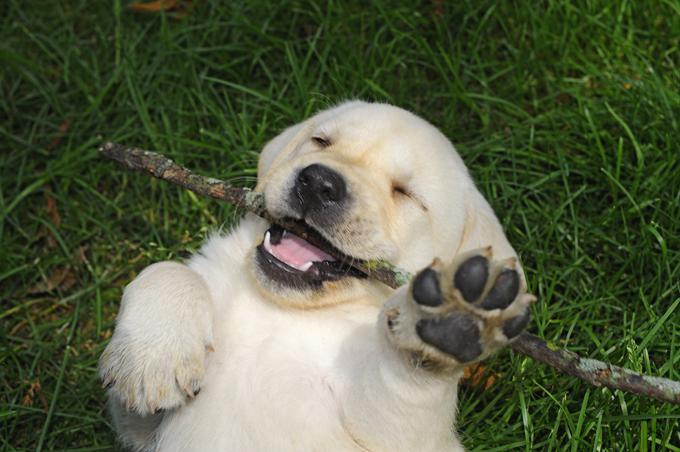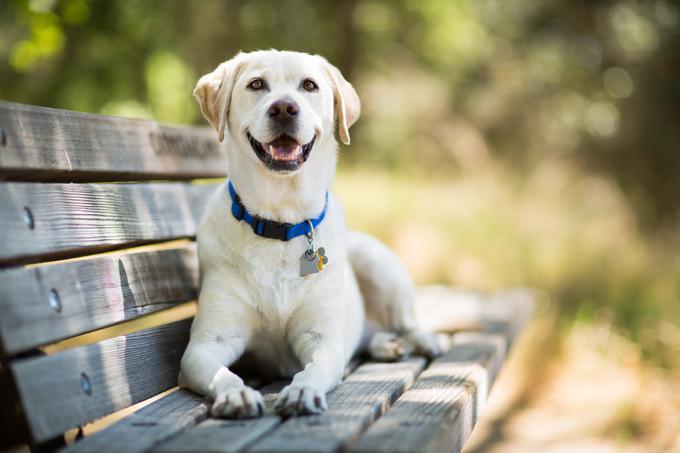The first image is the image on the left, the second image is the image on the right. Considering the images on both sides, is "In 1 of the images, 1 dog is seated on an artificial surface." valid? Answer yes or no. Yes. 